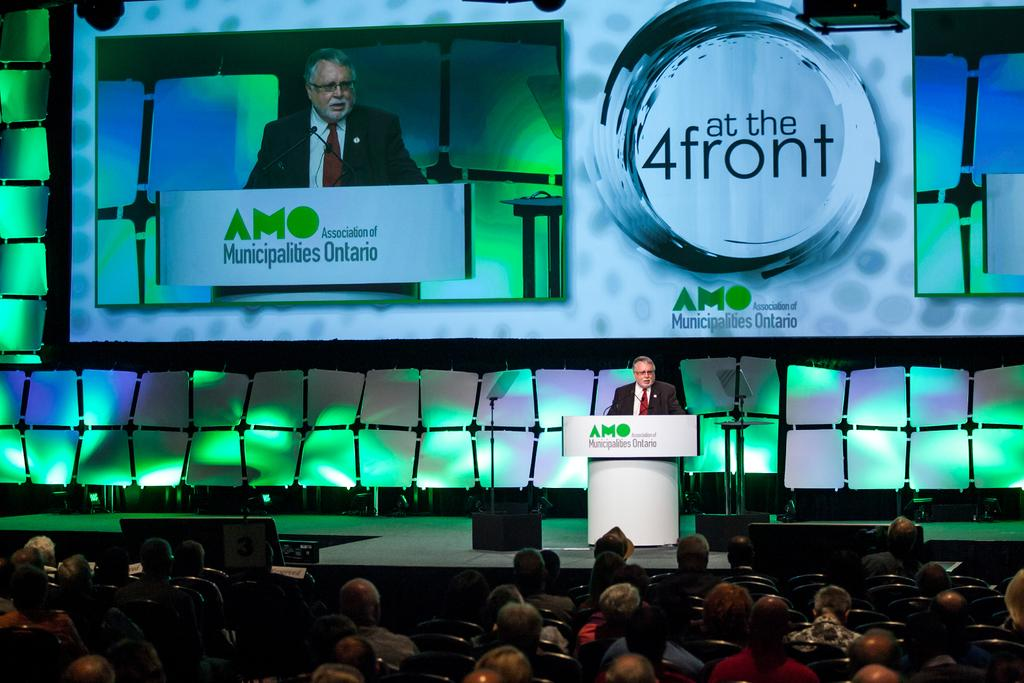What are the people in the image doing? There is a group of people sitting on chairs in the image. What is the man on the stage doing? The man standing on the stage is likely giving a presentation or speech. What object is present on the stage? There is a podium in the image. What can be seen in the background of the image? There is a screen in the background of the image. What type of pot is being used by the man on the stage? There is no pot present in the image; the man is standing on a stage with a podium. What color are the teeth of the people sitting on chairs? We cannot determine the color of the teeth of the people sitting on chairs from the image, as their mouths are not visible. 